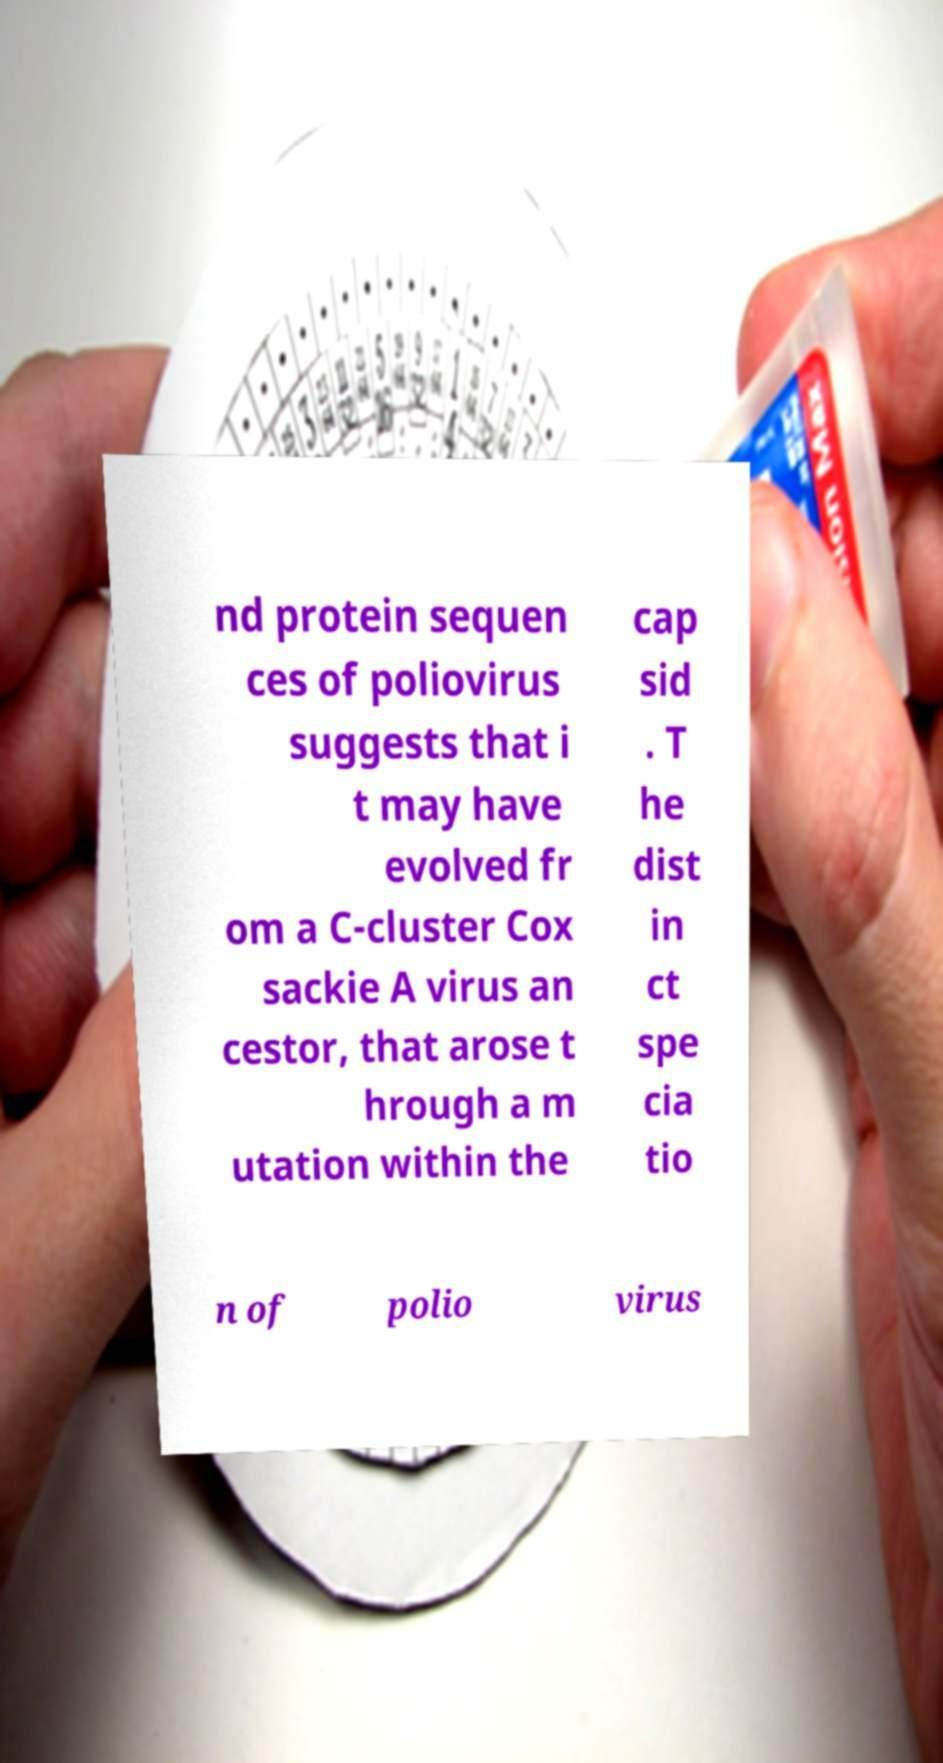Could you assist in decoding the text presented in this image and type it out clearly? nd protein sequen ces of poliovirus suggests that i t may have evolved fr om a C-cluster Cox sackie A virus an cestor, that arose t hrough a m utation within the cap sid . T he dist in ct spe cia tio n of polio virus 